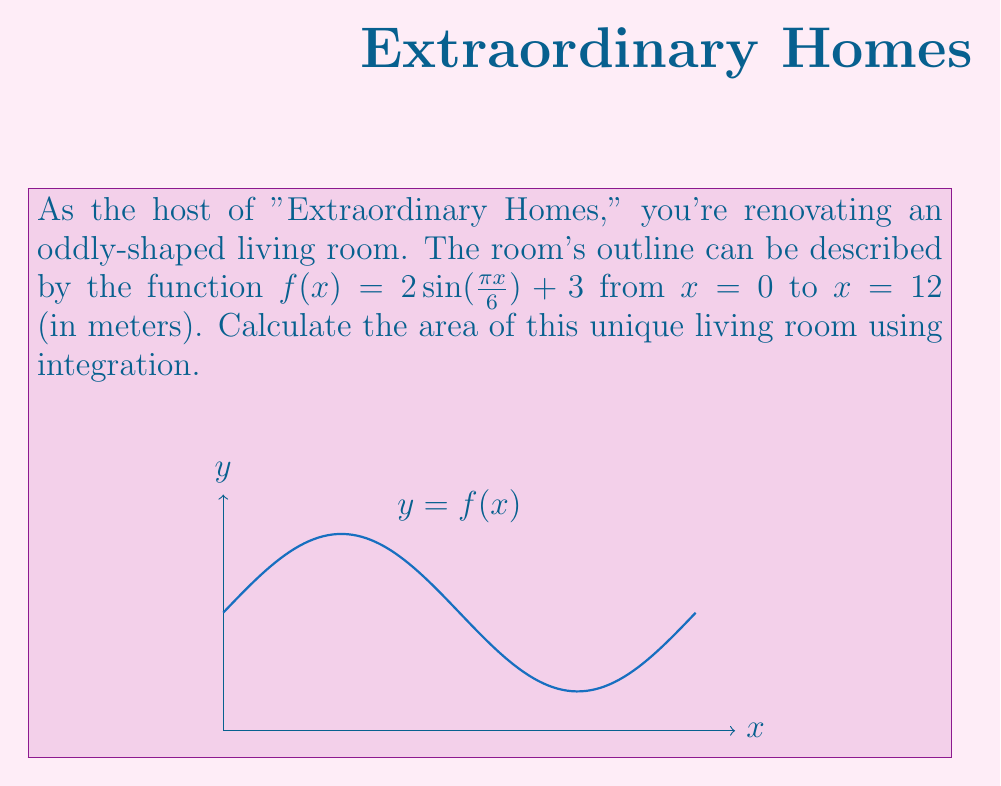Solve this math problem. To calculate the area of this irregular-shaped room, we need to use definite integration. The steps are as follows:

1) The area under a curve $y = f(x)$ from $a$ to $b$ is given by the definite integral:

   $$A = \int_{a}^{b} f(x) dx$$

2) In this case, $f(x) = 2\sin(\frac{\pi x}{6}) + 3$, $a = 0$, and $b = 12$. So our integral becomes:

   $$A = \int_{0}^{12} (2\sin(\frac{\pi x}{6}) + 3) dx$$

3) We can split this into two integrals:

   $$A = \int_{0}^{12} 2\sin(\frac{\pi x}{6}) dx + \int_{0}^{12} 3 dx$$

4) For the first integral, we use the substitution $u = \frac{\pi x}{6}$, so $du = \frac{\pi}{6} dx$ or $dx = \frac{6}{\pi} du$:

   $$\int_{0}^{12} 2\sin(\frac{\pi x}{6}) dx = \frac{12}{\pi} \int_{0}^{2\pi} \sin(u) du = \frac{12}{\pi} [-\cos(u)]_{0}^{2\pi} = \frac{12}{\pi} [(-\cos(2\pi)) - (-\cos(0))] = 0$$

5) The second integral is straightforward:

   $$\int_{0}^{12} 3 dx = 3x \big|_{0}^{12} = 36$$

6) Adding the results from steps 4 and 5:

   $$A = 0 + 36 = 36$$

Therefore, the area of the living room is 36 square meters.
Answer: 36 m² 